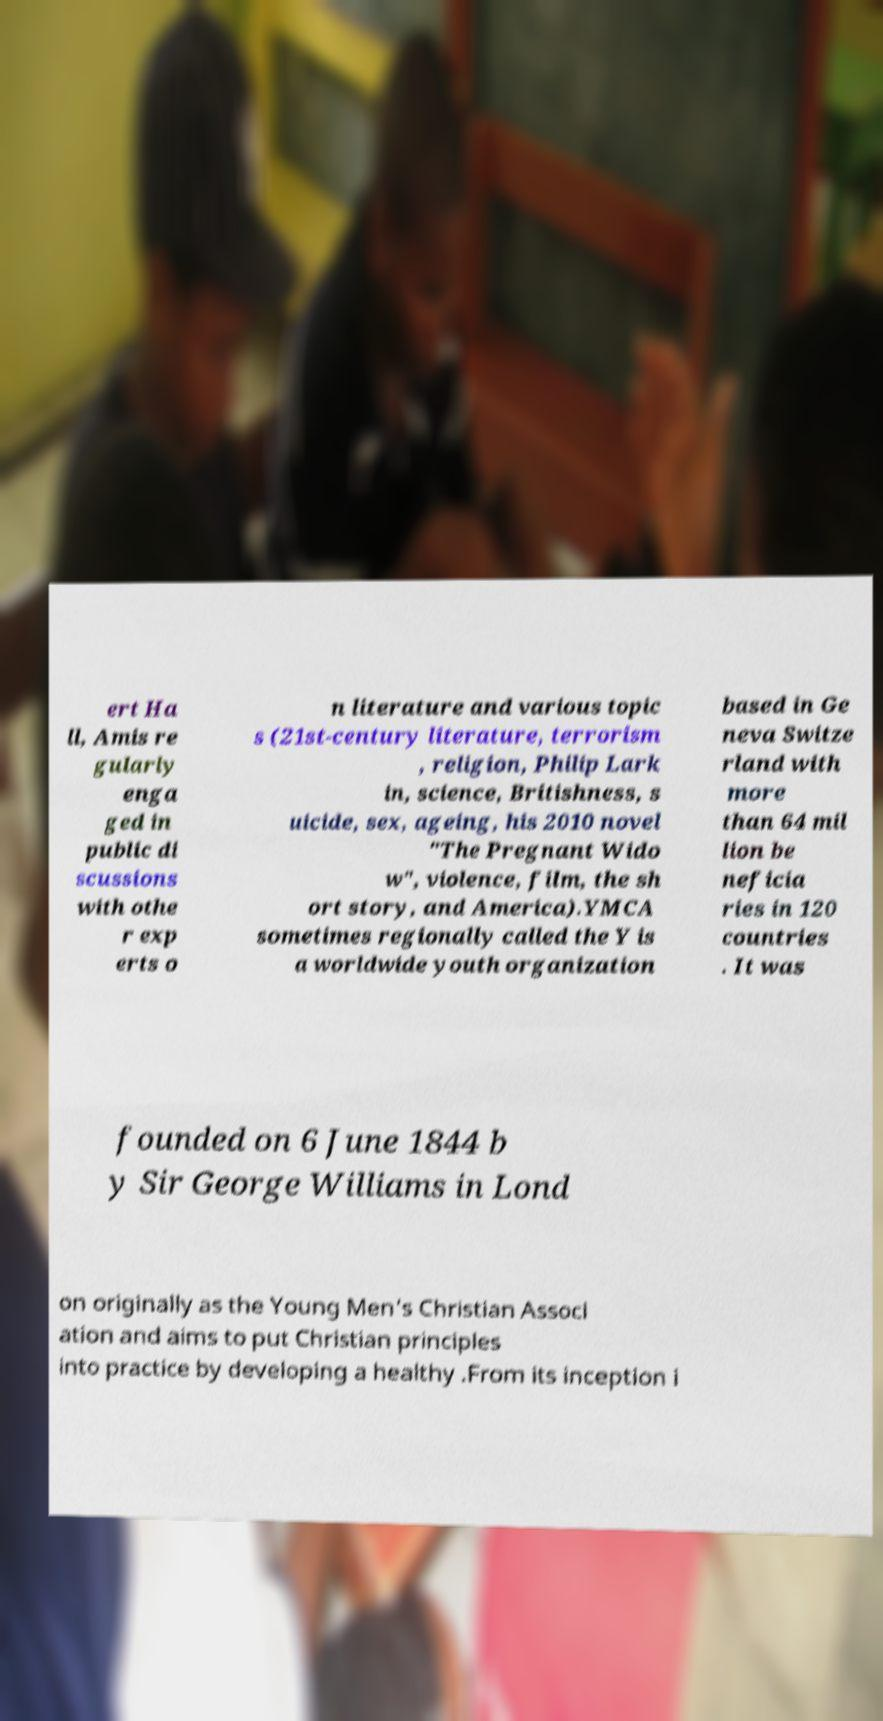Could you assist in decoding the text presented in this image and type it out clearly? ert Ha ll, Amis re gularly enga ged in public di scussions with othe r exp erts o n literature and various topic s (21st-century literature, terrorism , religion, Philip Lark in, science, Britishness, s uicide, sex, ageing, his 2010 novel "The Pregnant Wido w", violence, film, the sh ort story, and America).YMCA sometimes regionally called the Y is a worldwide youth organization based in Ge neva Switze rland with more than 64 mil lion be neficia ries in 120 countries . It was founded on 6 June 1844 b y Sir George Williams in Lond on originally as the Young Men's Christian Associ ation and aims to put Christian principles into practice by developing a healthy .From its inception i 